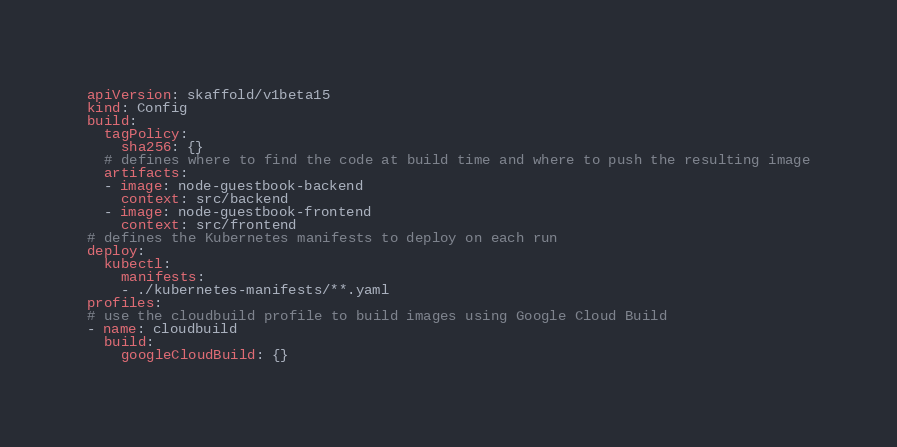Convert code to text. <code><loc_0><loc_0><loc_500><loc_500><_YAML_>
apiVersion: skaffold/v1beta15
kind: Config
build:
  tagPolicy:
    sha256: {}
  # defines where to find the code at build time and where to push the resulting image
  artifacts:
  - image: node-guestbook-backend
    context: src/backend
  - image: node-guestbook-frontend
    context: src/frontend
# defines the Kubernetes manifests to deploy on each run
deploy:
  kubectl:
    manifests:
    - ./kubernetes-manifests/**.yaml
profiles:
# use the cloudbuild profile to build images using Google Cloud Build
- name: cloudbuild
  build:
    googleCloudBuild: {}</code> 